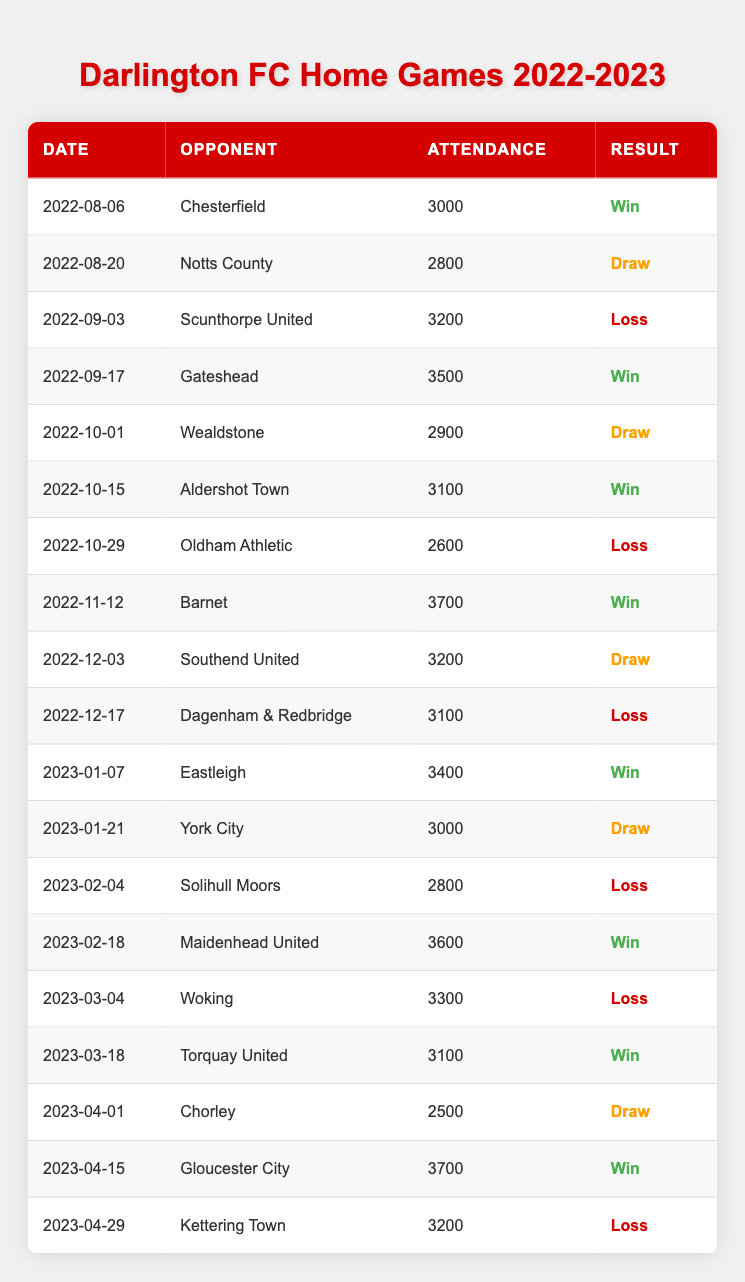What was the attendance for the game against Chesterfield? The attendance figure for the match against Chesterfield on August 6, 2022, is directly listed in the table, which shows 3000 as the attendance.
Answer: 3000 Which game had the highest attendance? By reviewing the attendance figures in the table, the highest attendance was 3700 for the games against Barnet on November 12, 2022, and Gloucester City on April 15, 2023.
Answer: 3700 How many games did Darlington FC win at home? The table outlines the results for each match, and counting the games labeled "Win", there are 8 wins from the total of 18 matches played.
Answer: 8 What is the average attendance for home games? To find the average attendance, we sum all attendance figures (3000 + 2800 + 3200 + 3500 + 2900 + 3100 + 2600 + 3700 + 3200 + 3100 + 3400 + 3000 + 2800 + 3600 + 3300 + 3100 + 2500 + 3700 + 3200 = 56800) and divide by the total number of games (18), resulting in an average attendance of 3155.56, which rounds to approximately 3156.
Answer: 3156 Did Darlington FC lose more games than they won at home? By counting the results in the table, there are 8 wins and 6 losses. Since Darlington won more games than they lost, the answer is no.
Answer: No In which month did Darlington FC have the highest attendance? The table shows that the highest attendance recorded was in November (3700 against Barnet) and April (3700 against Gloucester City), both occurring in different months but with the same attendance figure. One can conclude that both months had the highest attendance of 3700, thus they are tied.
Answer: November and April What was the result of the game on January 21, 2023? The table lists the result for the match against York City on January 21, 2023, which shows a "Draw" as the outcome.
Answer: Draw What is the difference in attendance between the game against Gateshead and the game against Kettering Town? The attendance for Gateshead is 3500, and for Kettering Town is 3200. The difference is calculated by subtracting the attendance of Kettering Town from that of Gateshead (3500 - 3200 = 300).
Answer: 300 How many games resulted in a draw? By scanning the results in the table, the matches that ended in a draw are against Notts County, Wealdstone, Southend United, York City, and Chorley, totaling 5 drawn matches.
Answer: 5 